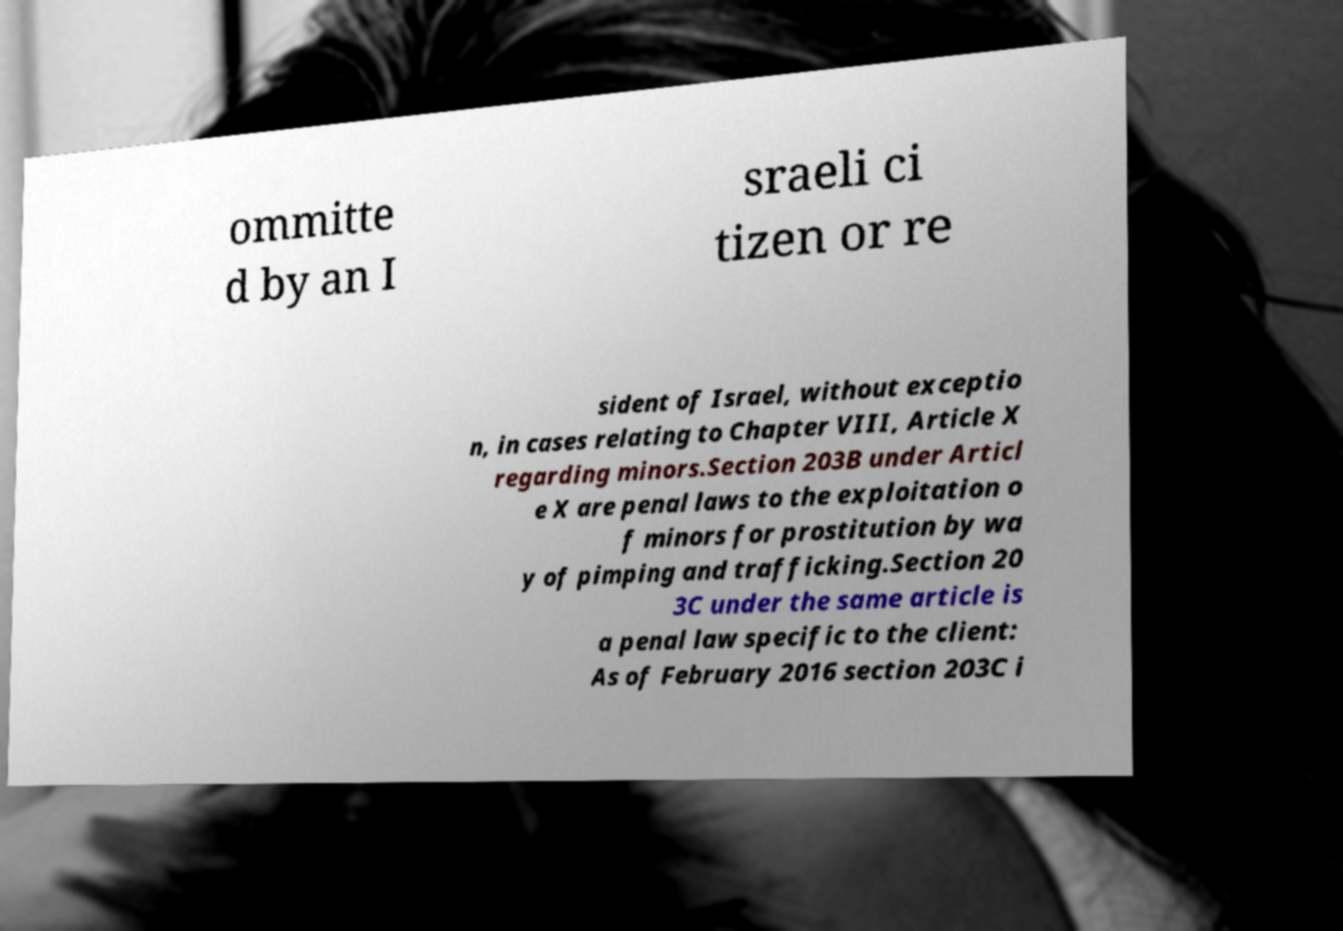There's text embedded in this image that I need extracted. Can you transcribe it verbatim? ommitte d by an I sraeli ci tizen or re sident of Israel, without exceptio n, in cases relating to Chapter VIII, Article X regarding minors.Section 203B under Articl e X are penal laws to the exploitation o f minors for prostitution by wa y of pimping and trafficking.Section 20 3C under the same article is a penal law specific to the client: As of February 2016 section 203C i 